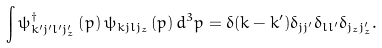<formula> <loc_0><loc_0><loc_500><loc_500>\int \psi _ { k ^ { \prime } j ^ { \prime } l ^ { \prime } j _ { z } ^ { \prime } } ^ { \dagger } \left ( p \right ) \psi _ { k j l j _ { z } } \left ( p \right ) d ^ { 3 } p = \delta ( k - k ^ { \prime } ) \delta _ { j j ^ { \prime } } \delta _ { l l ^ { \prime } } \delta _ { j _ { z } j _ { z } ^ { \prime } } .</formula> 